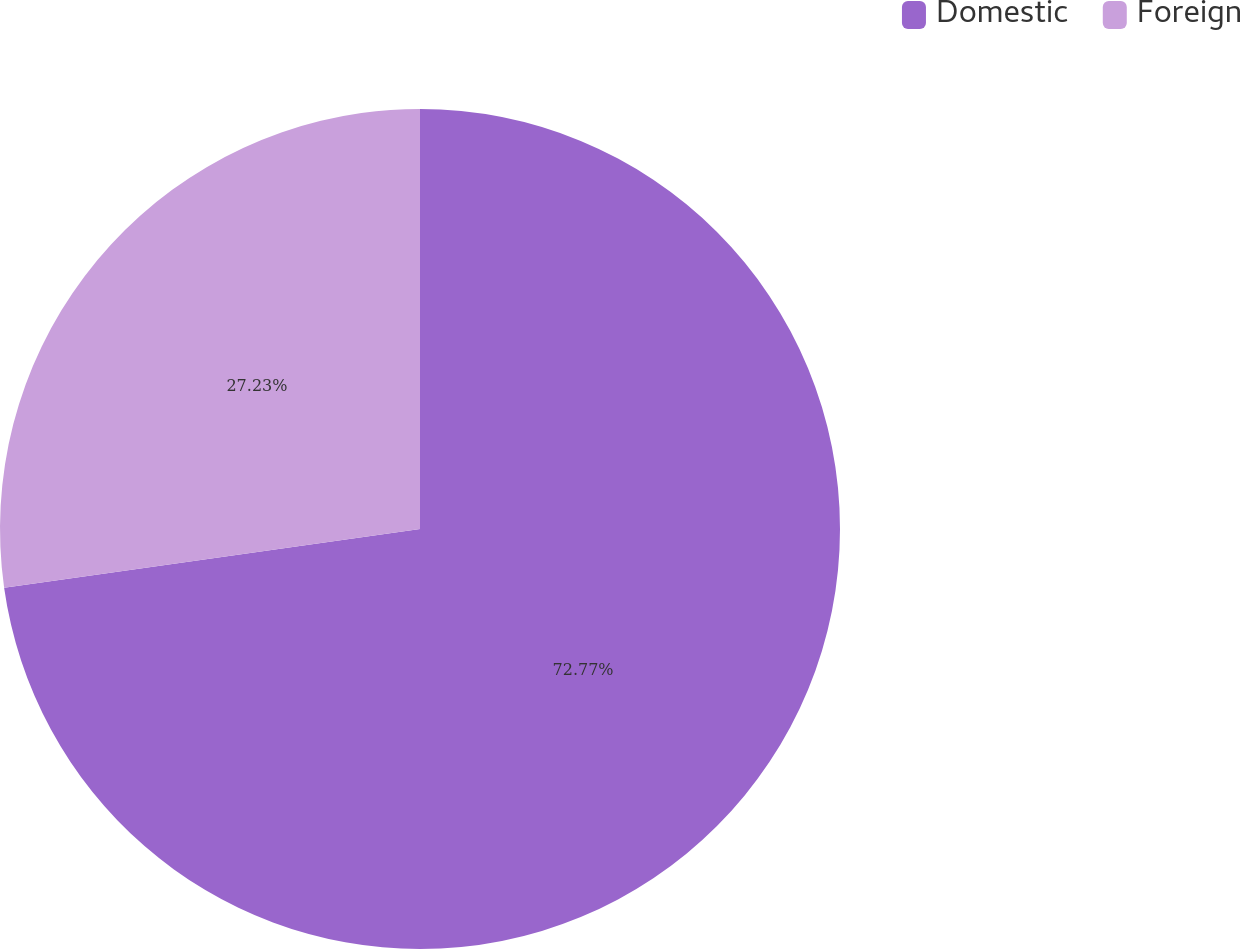<chart> <loc_0><loc_0><loc_500><loc_500><pie_chart><fcel>Domestic<fcel>Foreign<nl><fcel>72.77%<fcel>27.23%<nl></chart> 